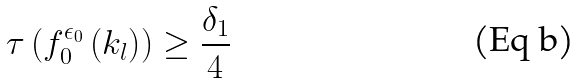Convert formula to latex. <formula><loc_0><loc_0><loc_500><loc_500>\tau \left ( f ^ { \epsilon _ { 0 } } _ { 0 } \left ( k _ { l } \right ) \right ) \geq \frac { \delta _ { 1 } } { 4 }</formula> 